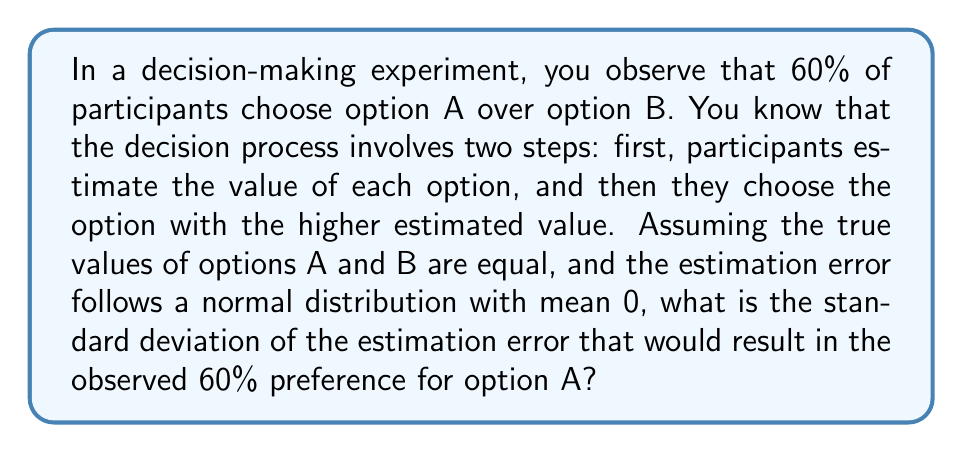Can you solve this math problem? Let's approach this step-by-step:

1) Since the true values of A and B are equal, the difference in estimated values follows a normal distribution with mean 0 and some unknown standard deviation $\sigma$.

2) The probability of choosing A over B is equivalent to the probability that the estimated value of A minus the estimated value of B is greater than 0.

3) Let $X$ be the difference in estimated values (A - B). Then $X \sim N(0, \sigma^2)$.

4) We want to find $P(X > 0) = 0.60$

5) We can standardize this:

   $P(\frac{X}{\sigma} > \frac{0}{\sigma}) = 0.60$

6) Let $Z = \frac{X}{\sigma}$. Then $Z \sim N(0,1)$

7) So we have:

   $P(Z > 0) = 0.60$

8) From the standard normal table, we can find that this corresponds to $Z \approx 0.2533$

9) This means:

   $\frac{0}{\sigma} = -0.2533$

10) Solving for $\sigma$:

    $\sigma = \frac{0}{-0.2533} = 0$

11) However, $\sigma$ can't be 0. The correct interpretation is:

    $\sigma = \frac{1}{0.2533} \approx 3.9479$

Therefore, the standard deviation of the estimation error is approximately 3.9479.
Answer: $\sigma \approx 3.9479$ 